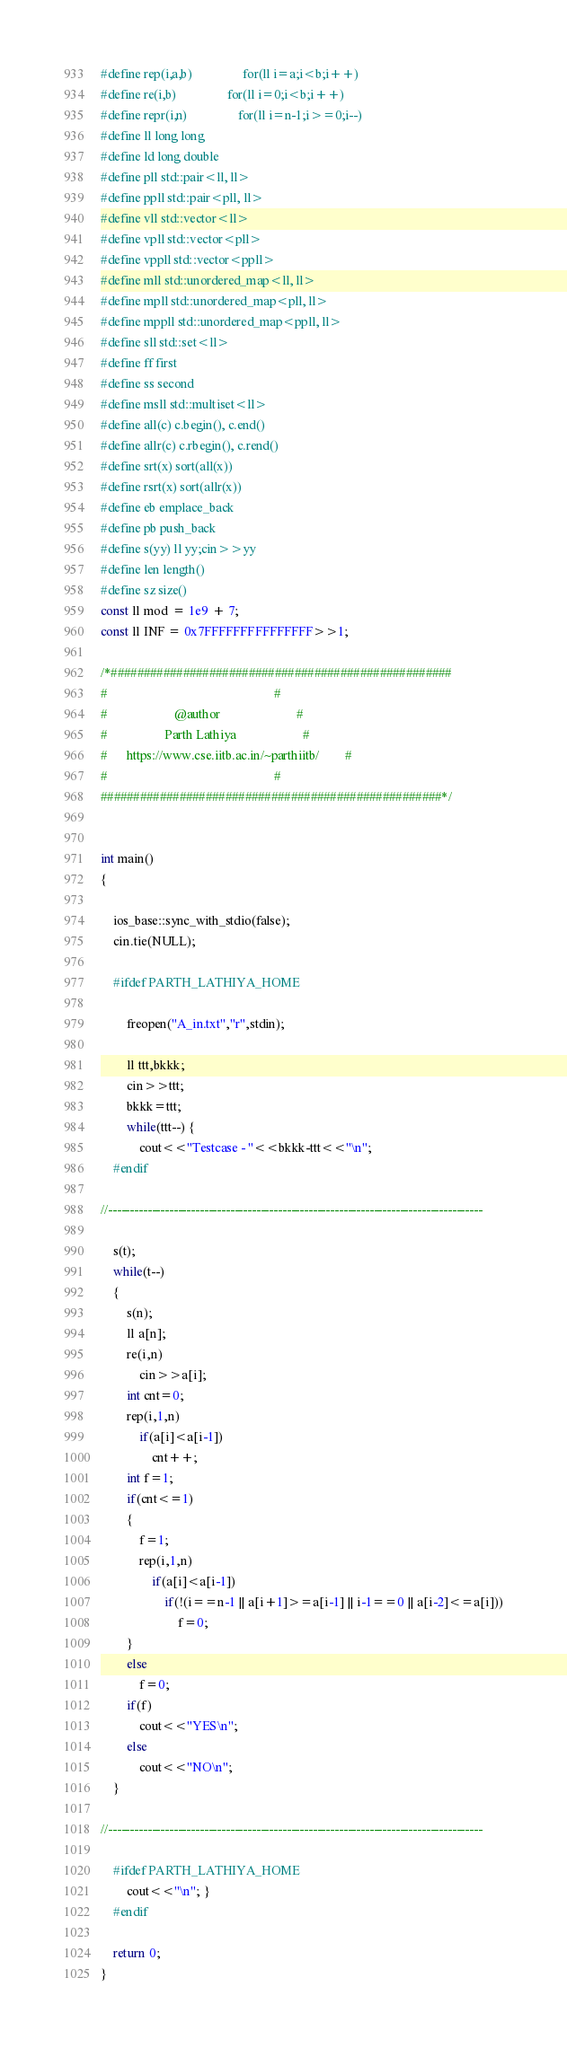Convert code to text. <code><loc_0><loc_0><loc_500><loc_500><_C++_>
#define rep(i,a,b)                for(ll i=a;i<b;i++)
#define re(i,b)                for(ll i=0;i<b;i++)
#define repr(i,n)                for(ll i=n-1;i>=0;i--)
#define ll long long
#define ld long double
#define pll std::pair<ll, ll> 
#define ppll std::pair<pll, ll>
#define vll std::vector<ll> 
#define vpll std::vector<pll> 
#define vppll std::vector<ppll> 
#define mll std::unordered_map<ll, ll> 
#define mpll std::unordered_map<pll, ll>
#define mppll std::unordered_map<ppll, ll>
#define sll std::set<ll>
#define ff first
#define ss second
#define msll std::multiset<ll>
#define all(c) c.begin(), c.end()
#define allr(c) c.rbegin(), c.rend()
#define srt(x) sort(all(x))
#define rsrt(x) sort(allr(x))
#define eb emplace_back
#define pb push_back
#define s(yy) ll yy;cin>>yy
#define len length()
#define sz size()
const ll mod = 1e9 + 7;
const ll INF = 0x7FFFFFFFFFFFFFFF>>1;

/*#################################################### 
#                                                    #
#                     @author                        #
#                  Parth Lathiya                     #
#      https://www.cse.iitb.ac.in/~parthiitb/        #
#                                                    #
####################################################*/


int main()
{

    ios_base::sync_with_stdio(false);
    cin.tie(NULL);

    #ifdef PARTH_LATHIYA_HOME

        freopen("A_in.txt","r",stdin);
    
        ll ttt,bkkk;
        cin>>ttt;
        bkkk=ttt;
        while(ttt--) {
            cout<<"Testcase - "<<bkkk-ttt<<"\n";
    #endif

//--------------------------------------------------------------------------------------

    s(t);
    while(t--)
    {
        s(n);
        ll a[n];
        re(i,n)
            cin>>a[i];
        int cnt=0;
        rep(i,1,n) 
            if(a[i]<a[i-1])
                cnt++;
        int f=1;
        if(cnt<=1)
        {
            f=1;
            rep(i,1,n) 
                if(a[i]<a[i-1])
                    if(!(i==n-1 || a[i+1]>=a[i-1] || i-1==0 || a[i-2]<=a[i]))
                        f=0;
        }  
        else
            f=0;
        if(f)
            cout<<"YES\n";
        else
            cout<<"NO\n";
    }

//--------------------------------------------------------------------------------------
    
    #ifdef PARTH_LATHIYA_HOME
        cout<<"\n"; }
    #endif

    return 0;
}</code> 